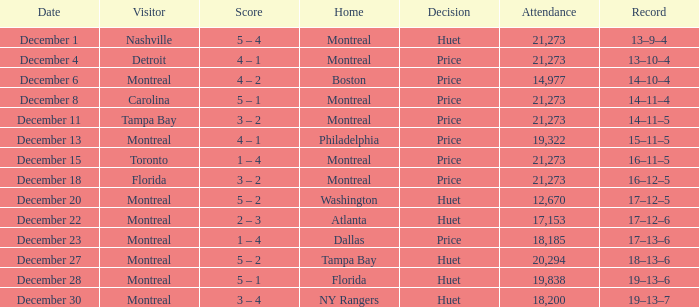What is the score when philadelphia participates at home? 4 – 1. 